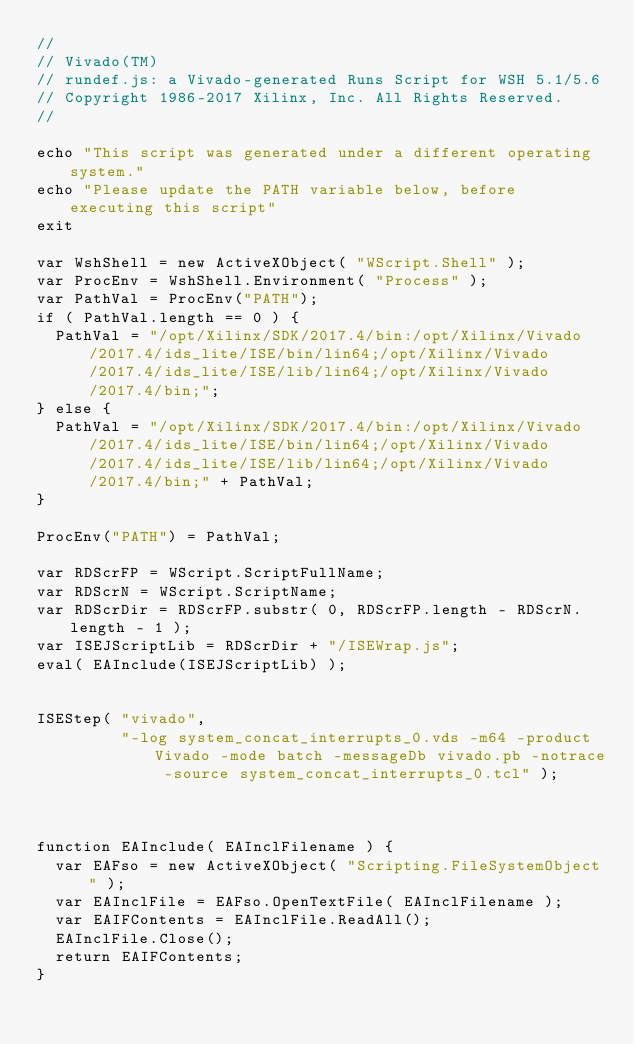<code> <loc_0><loc_0><loc_500><loc_500><_JavaScript_>//
// Vivado(TM)
// rundef.js: a Vivado-generated Runs Script for WSH 5.1/5.6
// Copyright 1986-2017 Xilinx, Inc. All Rights Reserved.
//

echo "This script was generated under a different operating system."
echo "Please update the PATH variable below, before executing this script"
exit

var WshShell = new ActiveXObject( "WScript.Shell" );
var ProcEnv = WshShell.Environment( "Process" );
var PathVal = ProcEnv("PATH");
if ( PathVal.length == 0 ) {
  PathVal = "/opt/Xilinx/SDK/2017.4/bin:/opt/Xilinx/Vivado/2017.4/ids_lite/ISE/bin/lin64;/opt/Xilinx/Vivado/2017.4/ids_lite/ISE/lib/lin64;/opt/Xilinx/Vivado/2017.4/bin;";
} else {
  PathVal = "/opt/Xilinx/SDK/2017.4/bin:/opt/Xilinx/Vivado/2017.4/ids_lite/ISE/bin/lin64;/opt/Xilinx/Vivado/2017.4/ids_lite/ISE/lib/lin64;/opt/Xilinx/Vivado/2017.4/bin;" + PathVal;
}

ProcEnv("PATH") = PathVal;

var RDScrFP = WScript.ScriptFullName;
var RDScrN = WScript.ScriptName;
var RDScrDir = RDScrFP.substr( 0, RDScrFP.length - RDScrN.length - 1 );
var ISEJScriptLib = RDScrDir + "/ISEWrap.js";
eval( EAInclude(ISEJScriptLib) );


ISEStep( "vivado",
         "-log system_concat_interrupts_0.vds -m64 -product Vivado -mode batch -messageDb vivado.pb -notrace -source system_concat_interrupts_0.tcl" );



function EAInclude( EAInclFilename ) {
  var EAFso = new ActiveXObject( "Scripting.FileSystemObject" );
  var EAInclFile = EAFso.OpenTextFile( EAInclFilename );
  var EAIFContents = EAInclFile.ReadAll();
  EAInclFile.Close();
  return EAIFContents;
}
</code> 